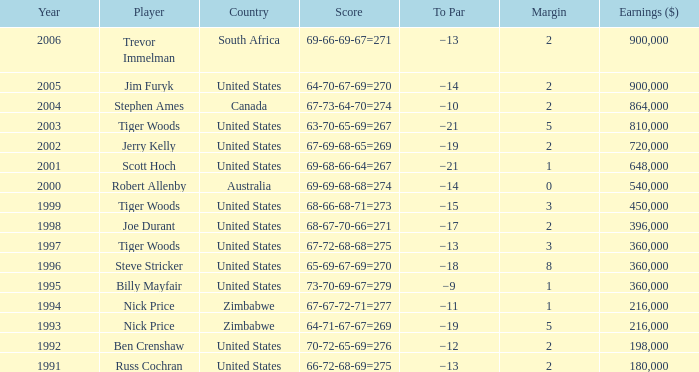Which To Par has Earnings ($) larger than 360,000, and a Year larger than 1998, and a Country of united states, and a Score of 69-68-66-64=267? −21. 